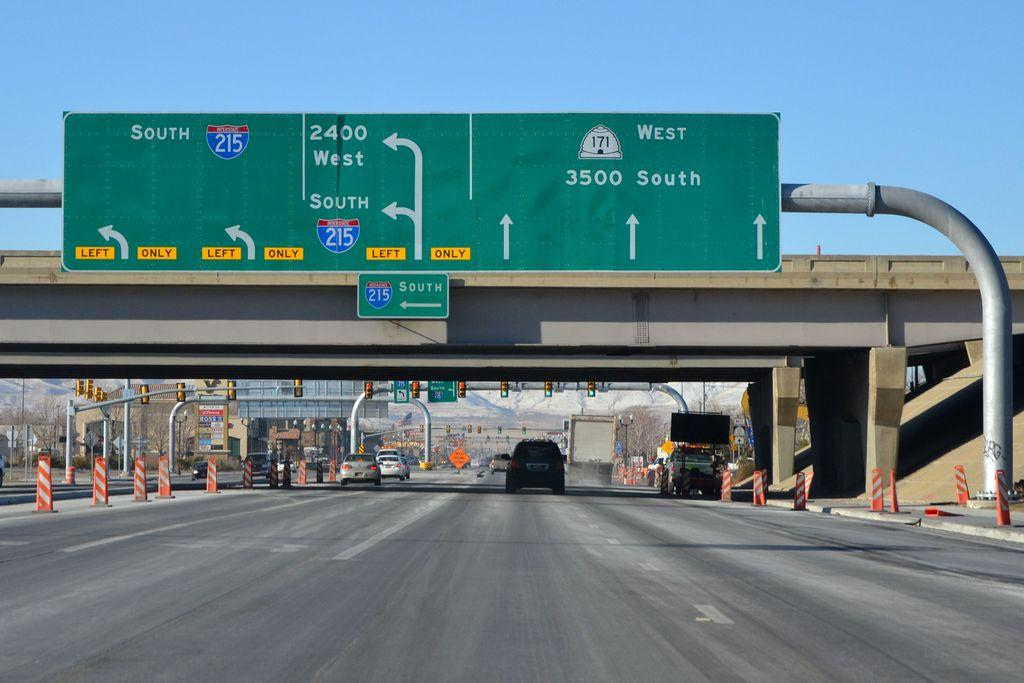Provide a one-sentence caption for the provided image. A green street sign shows exits to the west and the south. 